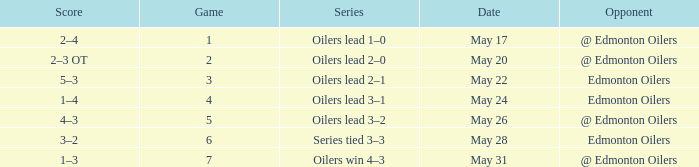Series of oilers win 4–3 had what highest game? 7.0. 